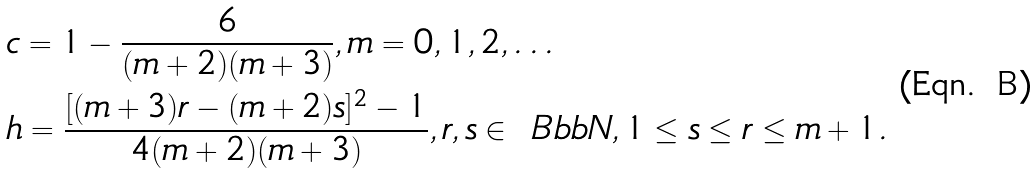<formula> <loc_0><loc_0><loc_500><loc_500>& c = 1 - \frac { 6 } { ( m + 2 ) ( m + 3 ) } , m = 0 , 1 , 2 , \dots \\ & h = \frac { [ ( m + 3 ) r - ( m + 2 ) s ] ^ { 2 } - 1 } { 4 ( m + 2 ) ( m + 3 ) } , r , s \in { \ B b b N } , 1 \leq s \leq r \leq m + 1 . \\</formula> 